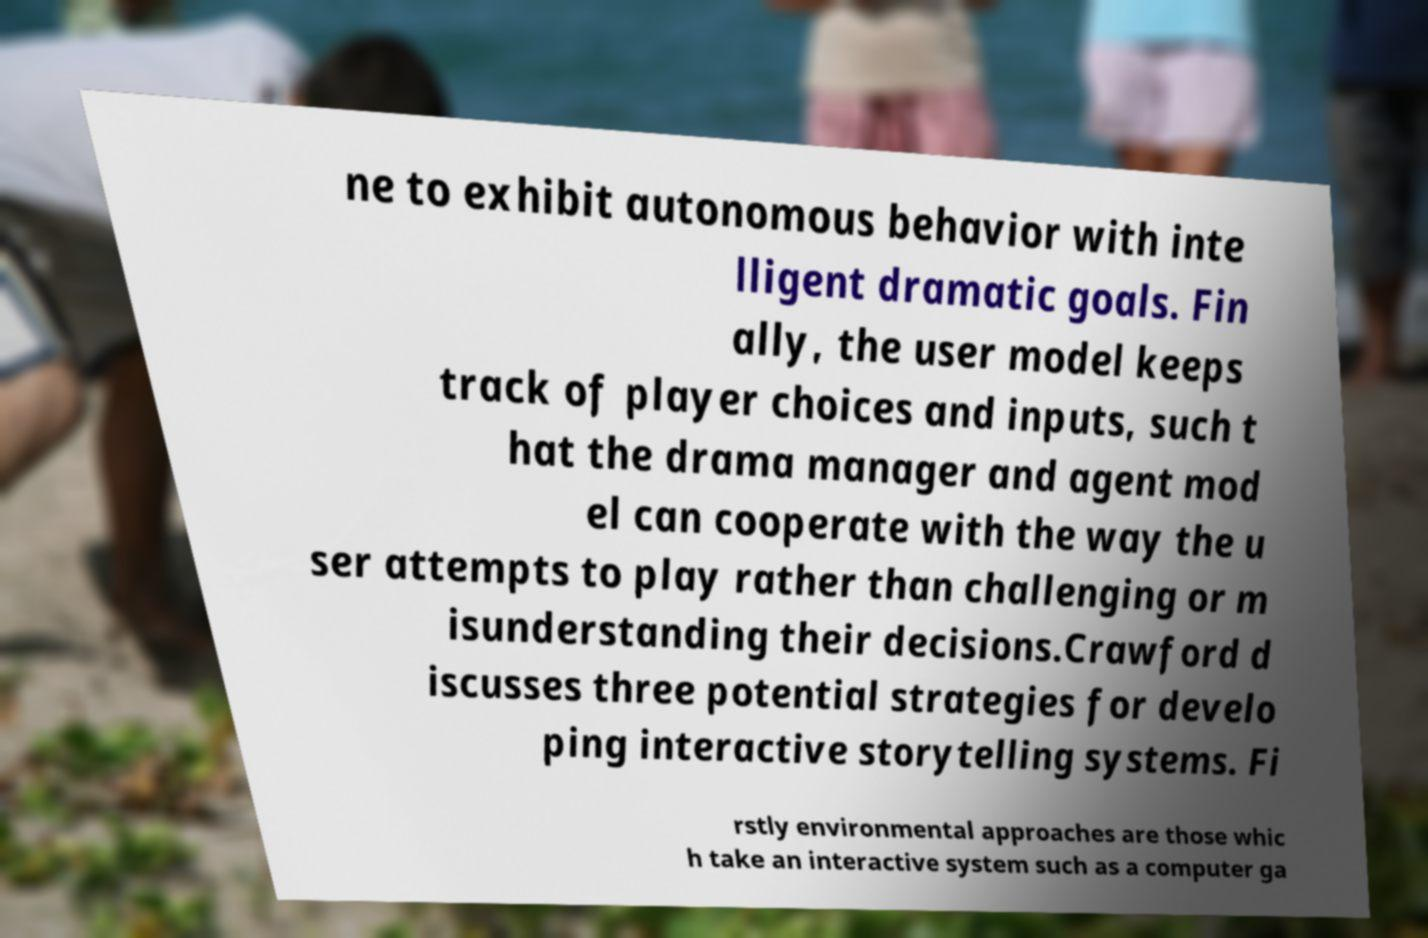I need the written content from this picture converted into text. Can you do that? ne to exhibit autonomous behavior with inte lligent dramatic goals. Fin ally, the user model keeps track of player choices and inputs, such t hat the drama manager and agent mod el can cooperate with the way the u ser attempts to play rather than challenging or m isunderstanding their decisions.Crawford d iscusses three potential strategies for develo ping interactive storytelling systems. Fi rstly environmental approaches are those whic h take an interactive system such as a computer ga 